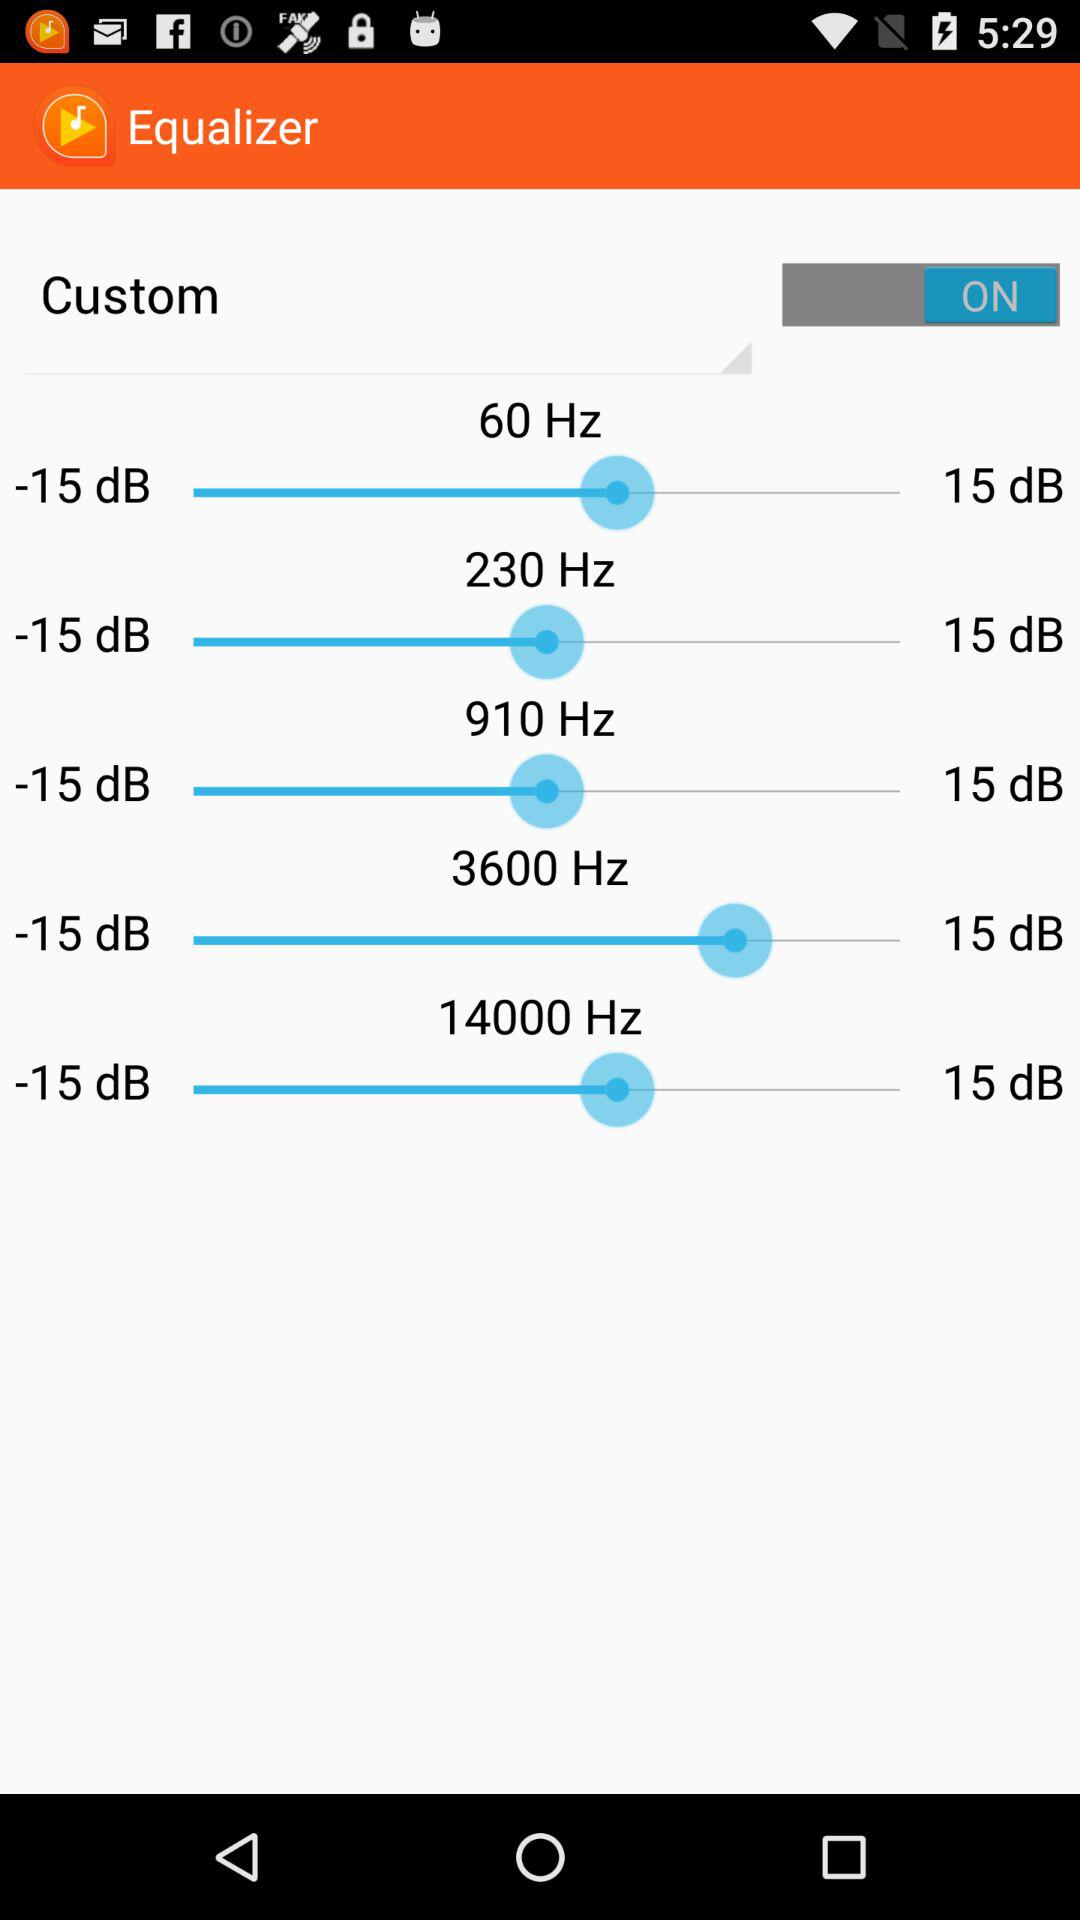How many frequencies are there in the custom equalizer?
Answer the question using a single word or phrase. 5 